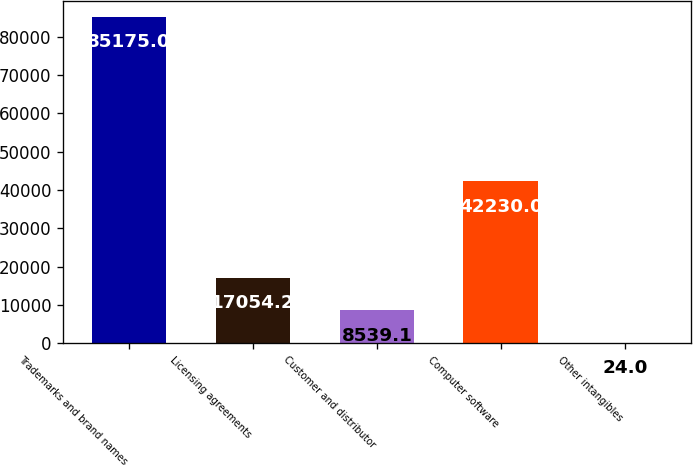Convert chart. <chart><loc_0><loc_0><loc_500><loc_500><bar_chart><fcel>Trademarks and brand names<fcel>Licensing agreements<fcel>Customer and distributor<fcel>Computer software<fcel>Other intangibles<nl><fcel>85175<fcel>17054.2<fcel>8539.1<fcel>42230<fcel>24<nl></chart> 